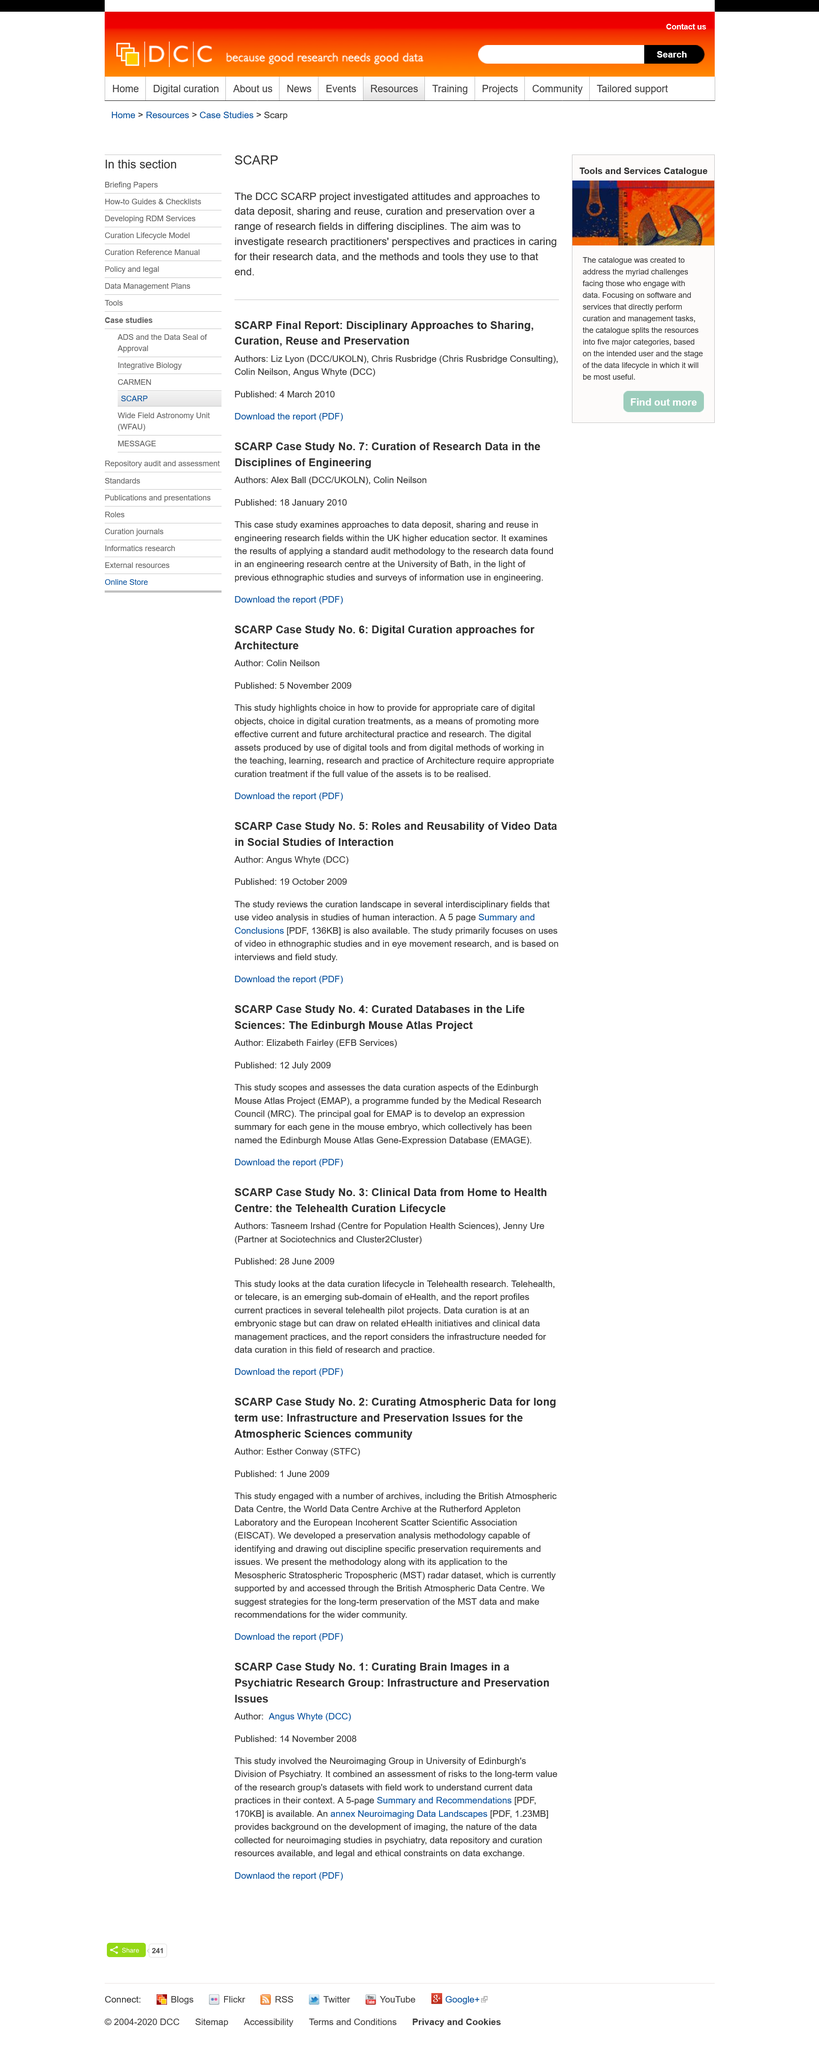Mention a couple of crucial points in this snapshot. The study was published on the 28th of June 2009. The SCARP Case Study No. 1 is known as "Curating Brain Images in a Psychiatric Research Group: Infrastructure and Preservation Issues. Tasneem Irshad and Jenny Ure are the authors of SCARP Case Study No. 3. The World Data Centre Archive is located at the Rutherford Appleton Laboratory. The study was conducted by the Neuroimaging Group in the University of Edinburgh's Division of Psychiatry. 